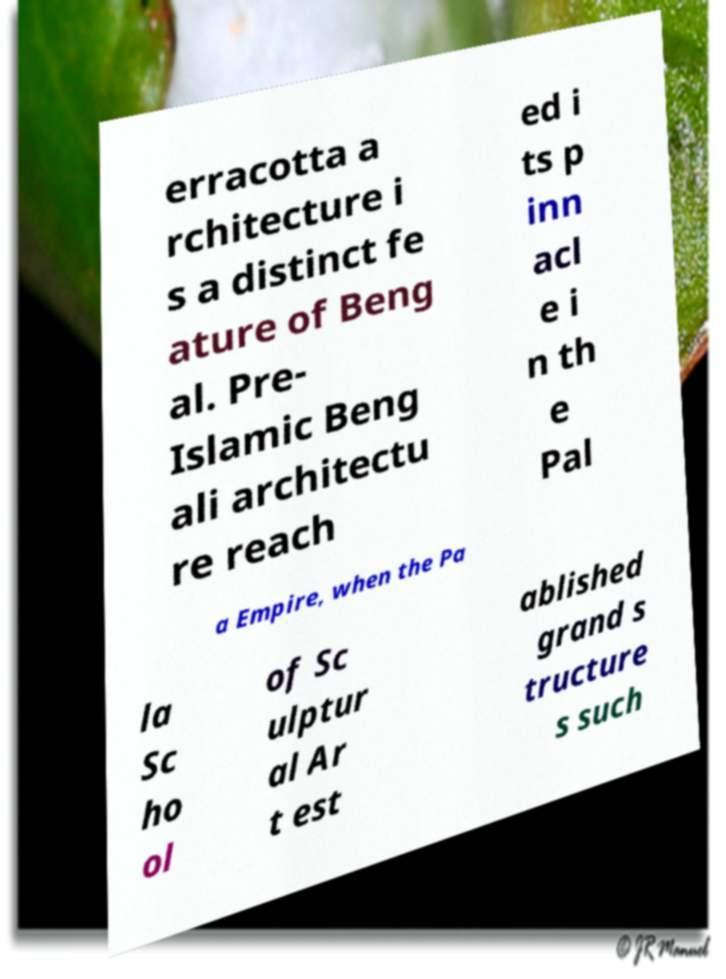Could you assist in decoding the text presented in this image and type it out clearly? erracotta a rchitecture i s a distinct fe ature of Beng al. Pre- Islamic Beng ali architectu re reach ed i ts p inn acl e i n th e Pal a Empire, when the Pa la Sc ho ol of Sc ulptur al Ar t est ablished grand s tructure s such 